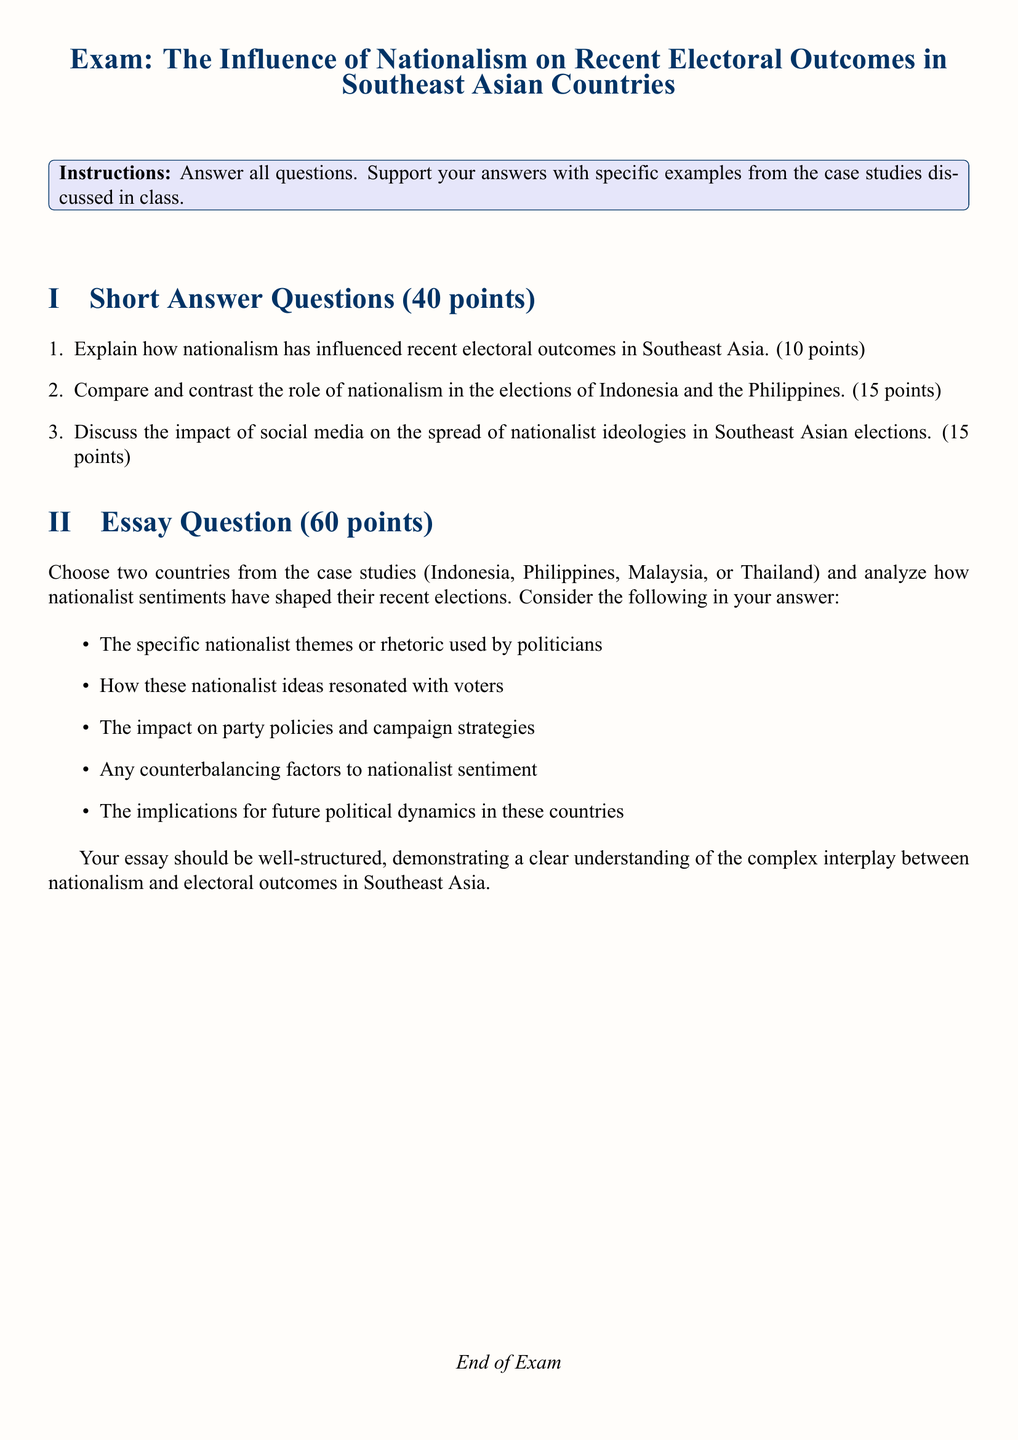What is the total number of points for the short answer questions? The total number of points allocated for the short answer questions is explicitly stated as 40 points.
Answer: 40 points What is the total number of points for the essay question? The total number of points assigned to the essay question is noted as 60 points.
Answer: 60 points How many countries are mentioned as case studies in the exam? The countries listed in the exam as case studies are four: Indonesia, Philippines, Malaysia, and Thailand.
Answer: Four What is the main focus of the exam? The exam focuses on the influence of nationalism on recent electoral outcomes in Southeast Asian countries.
Answer: Nationalism What are the instructions given at the beginning of the exam? The instructions specify that students should answer all questions and support their answers with specific examples from the case studies discussed in class.
Answer: Answer all questions How many short answer questions are included in the exam? The exam contains three short answer questions as indicated in the short answer questions section.
Answer: Three What type of analysis is required for the essay question? The essay question requires candidates to analyze how nationalist sentiments have shaped elections in two selected countries.
Answer: Analyze What should the essay analyze regarding nationalist themes? The essay should analyze specific nationalist themes or rhetoric used by politicians in the selected countries.
Answer: Nationalist themes Which section has 15 points each for its questions? The section concerning the comparison of nationalism in the elections of Indonesia and the Philippines carries 15 points.
Answer: Comparison section What is the format of the document? The document is in a structured exam format containing short answer questions and an essay question.
Answer: Exam format 